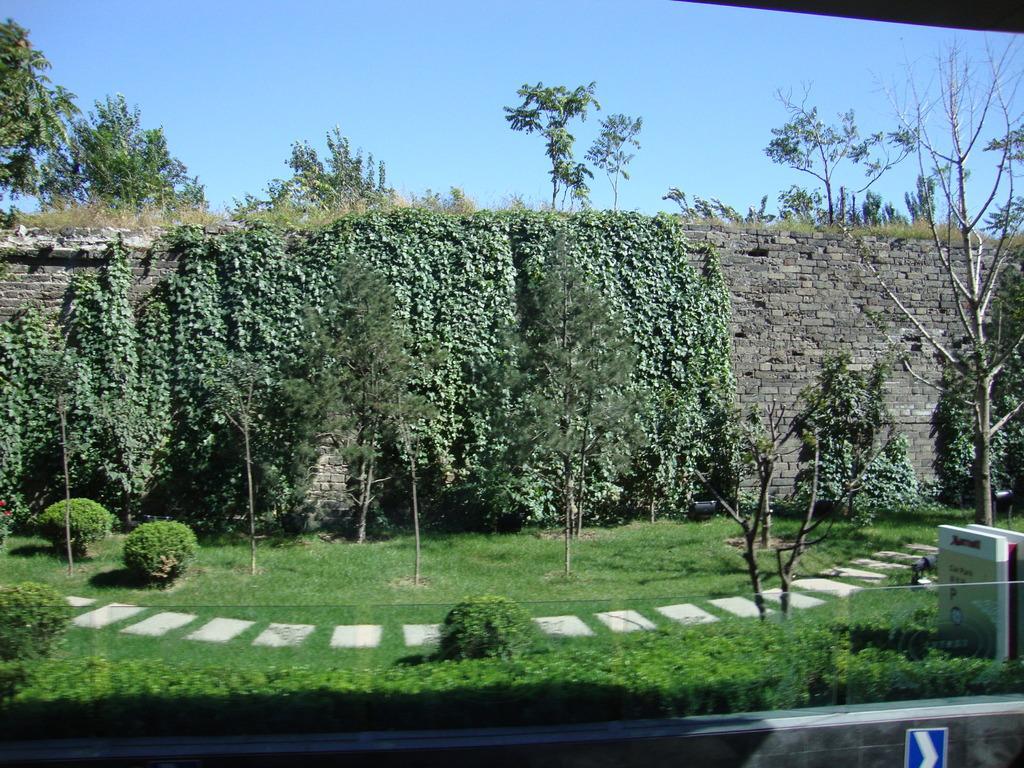Please provide a concise description of this image. In this picture there are trees and plants and there is a creeper on the wall. At the top there is sky. At the bottom there is grass and there is a pavement. On the right side of the image there are boards and there is text on the boards. At the bottom right it looks like a wall. 